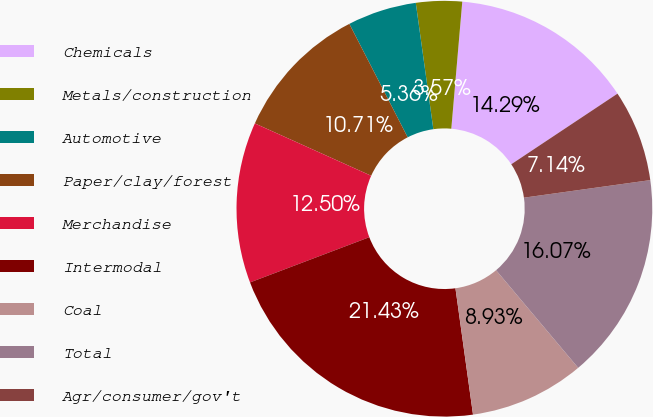Convert chart. <chart><loc_0><loc_0><loc_500><loc_500><pie_chart><fcel>Chemicals<fcel>Metals/construction<fcel>Automotive<fcel>Paper/clay/forest<fcel>Merchandise<fcel>Intermodal<fcel>Coal<fcel>Total<fcel>Agr/consumer/gov't<nl><fcel>14.29%<fcel>3.57%<fcel>5.36%<fcel>10.71%<fcel>12.5%<fcel>21.43%<fcel>8.93%<fcel>16.07%<fcel>7.14%<nl></chart> 